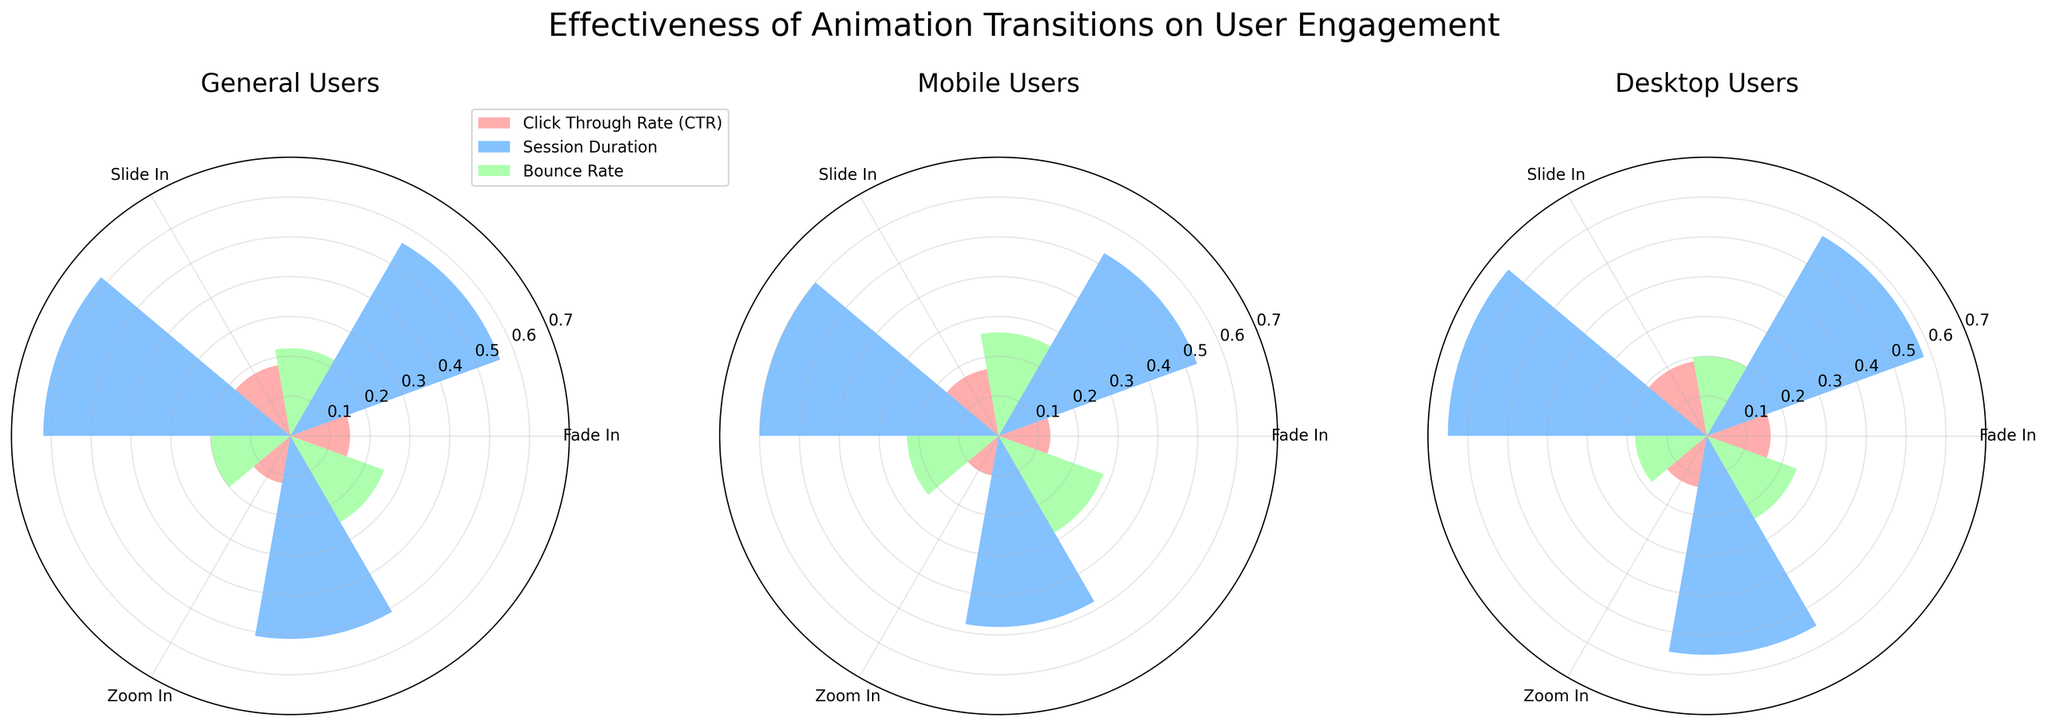Which transition type has the highest average Click Through Rate (CTR) across all user groups? To find the highest average CTR, we need to calculate the average CTR for each transition type across all user groups. Fade In: (0.15 + 0.13 + 0.16) / 3 = 0.1467, Slide In: (0.18 + 0.17 + 0.19) / 3 = 0.18, Zoom In: (0.12 + 0.10 + 0.13) / 3 = 0.1167. Slide In has the highest average CTR.
Answer: Slide In Which user group has the longest average session duration for the Slide In transition? We compare the session durations for the Slide In transition across all user groups. General Users: 6.2, Mobile Users: 6.0, Desktop Users: 6.5. The Desktop Users group has the longest average session duration.
Answer: Desktop Users What is the bounce rate difference between General Users and Mobile Users for the Fade In transition? General Users have a bounce rate of 0.22 with Fade In, while Mobile Users have a bounce rate of 0.26 with the same transition. Subtracting these gives: 0.26 - 0.22 = 0.04.
Answer: 0.04 Which transition type shows the lowest user engagement in any metric for Desktop Users? To identify the lowest user engagement metric for Desktop Users, we compare all values. For CTR: Fade In (0.16), Slide In (0.19), Zoom In (0.13). For Session Duration: Fade In (5.8), Slide In (6.5), Zoom In (5.5). For Bounce Rate: Fade In (0.20), Slide In (0.18), Zoom In (0.24). The lowest value is Zoom In CTR at 0.13.
Answer: Zoom In How do the bounce rates for Slide In transition compare across different user groups? Slide In bounce rates are: General Users (0.20), Mobile Users (0.23), Desktop Users (0.18). General Users and Desktop Users have lower bounce rates compared to Mobile Users. Desktop Users have the lowest.
Answer: Desktop Users have the lowest Which metric and user group combination shows the highest value for the Zoom In transition? Comparing values for Zoom In transition across metrics and user groups, we find: General Users: CTR (0.12), Session Duration (5.1), Bounce Rate (0.25). Mobile Users: CTR (0.10), Session Duration (4.8), Bounce Rate (0.28). Desktop Users: CTR (0.13), Session Duration (5.5), Bounce Rate (0.24). The highest value is the Mobile Users' Bounce Rate at 0.28.
Answer: Mobile Users' Bounce Rate What is the average Session Duration for General Users across all transitions? Calculating the average for General Users: (Fade In: 5.6, Slide In: 6.2, Zoom In: 5.1). Sum: 5.6 + 6.2 + 5.1 = 16.9. Average: 16.9 / 3 = 5.6333.
Answer: 5.63 Which transition type has the most balanced engagement metrics for Desktop Users? Comparing the variance among metrics for each transition type: Fade In (CTR: 0.16, Session: 5.8, Bounce: 0.20), Slide In (CTR: 0.19, Session: 6.5, Bounce: 0.18), Zoom In (CTR: 0.13, Session: 5.5, Bounce: 0.24). Slide In shows the most balanced engagement with the closest metric values.
Answer: Slide In For which user group and transition type is the difference between Session Duration and Bounce Rate the greatest? We need to calculate the difference for every combination. General Users: Fade In (5.6 - 0.22 = 5.38), Slide In (6.2 - 0.20 = 6.0), Zoom In (5.1 - 0.25 = 4.85). Mobile Users: Fade In (5.3 - 0.26 = 5.04), Slide In (6.0 - 0.23 = 5.77), Zoom In (4.8 - 0.28 = 4.52). Desktop Users: Fade In (5.8 - 0.20 = 5.60), Slide In (6.5 - 0.18 = 6.32), Zoom In (5.5 - 0.24 = 5.26). The greatest difference is General Users' Slide In at 6.0.
Answer: General Users' Slide In 